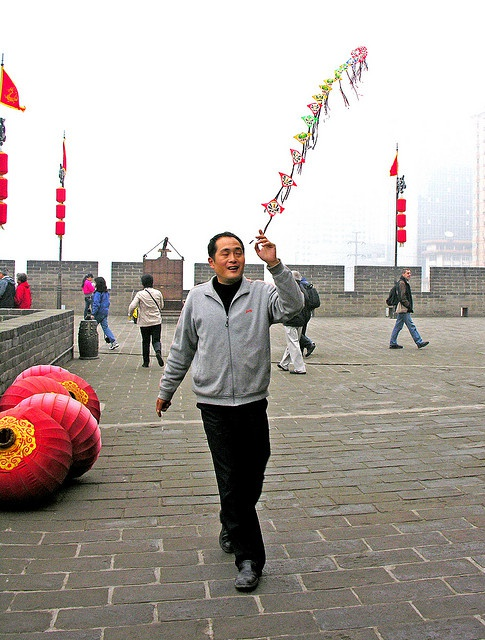Describe the objects in this image and their specific colors. I can see people in white, black, darkgray, gray, and lightgray tones, people in white, black, lightgray, darkgray, and gray tones, people in white, black, gray, and blue tones, people in white, darkgray, lightgray, gray, and black tones, and people in white, black, gray, and darkgray tones in this image. 